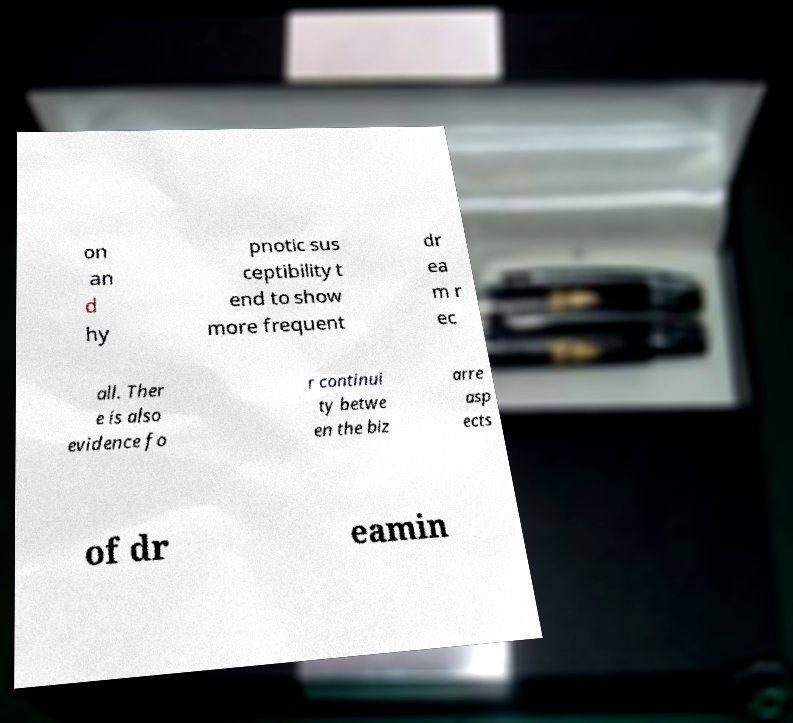For documentation purposes, I need the text within this image transcribed. Could you provide that? on an d hy pnotic sus ceptibility t end to show more frequent dr ea m r ec all. Ther e is also evidence fo r continui ty betwe en the biz arre asp ects of dr eamin 